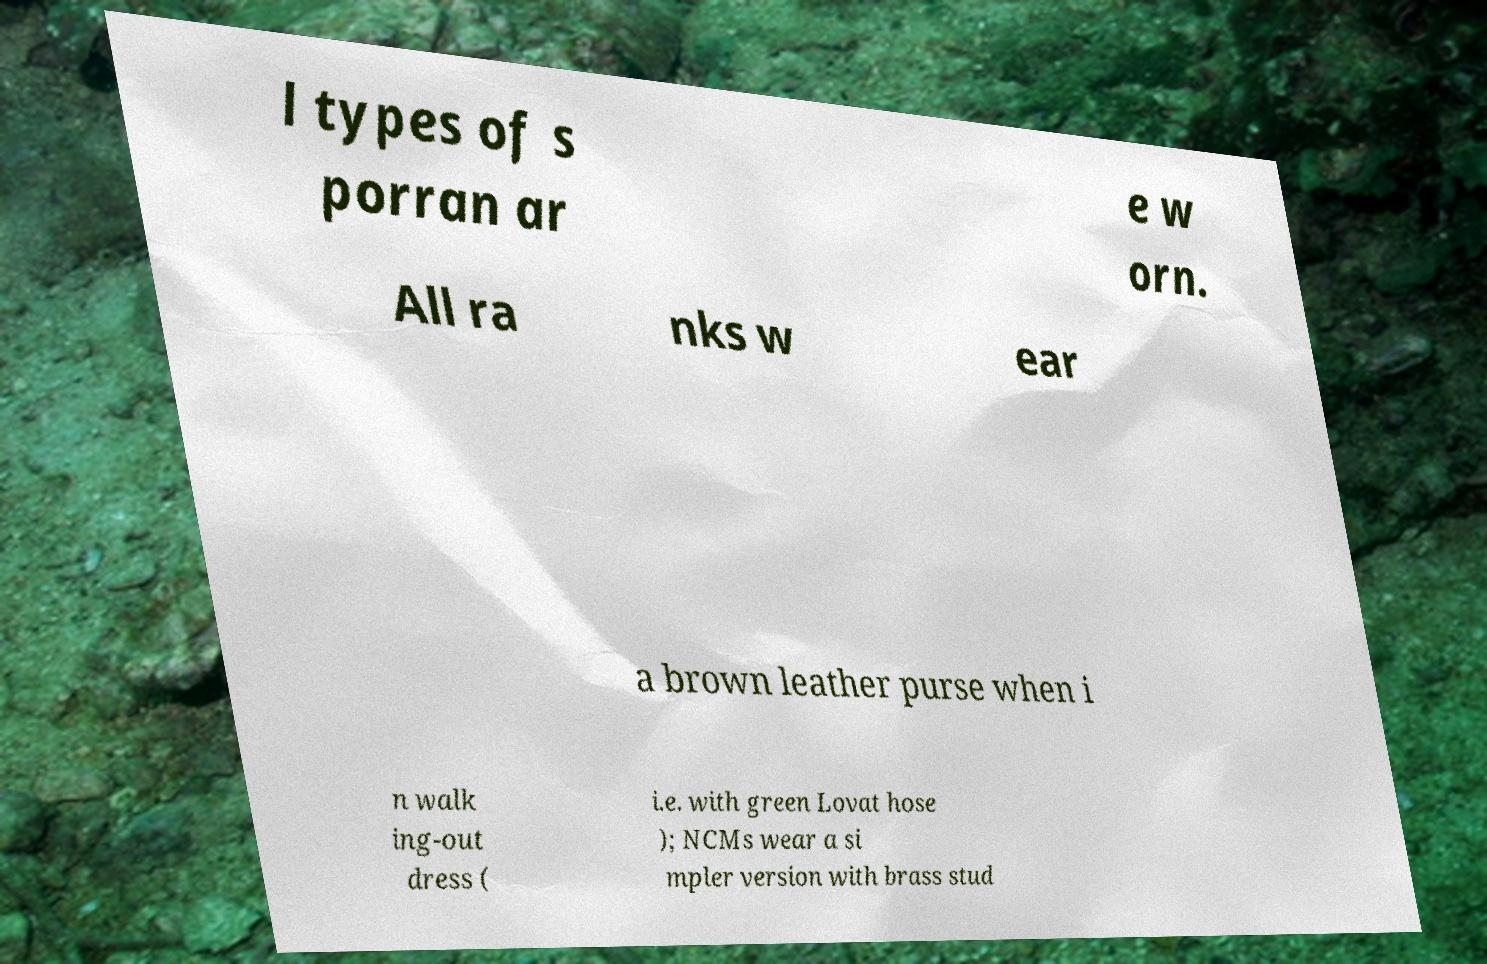Please read and relay the text visible in this image. What does it say? l types of s porran ar e w orn. All ra nks w ear a brown leather purse when i n walk ing-out dress ( i.e. with green Lovat hose ); NCMs wear a si mpler version with brass stud 